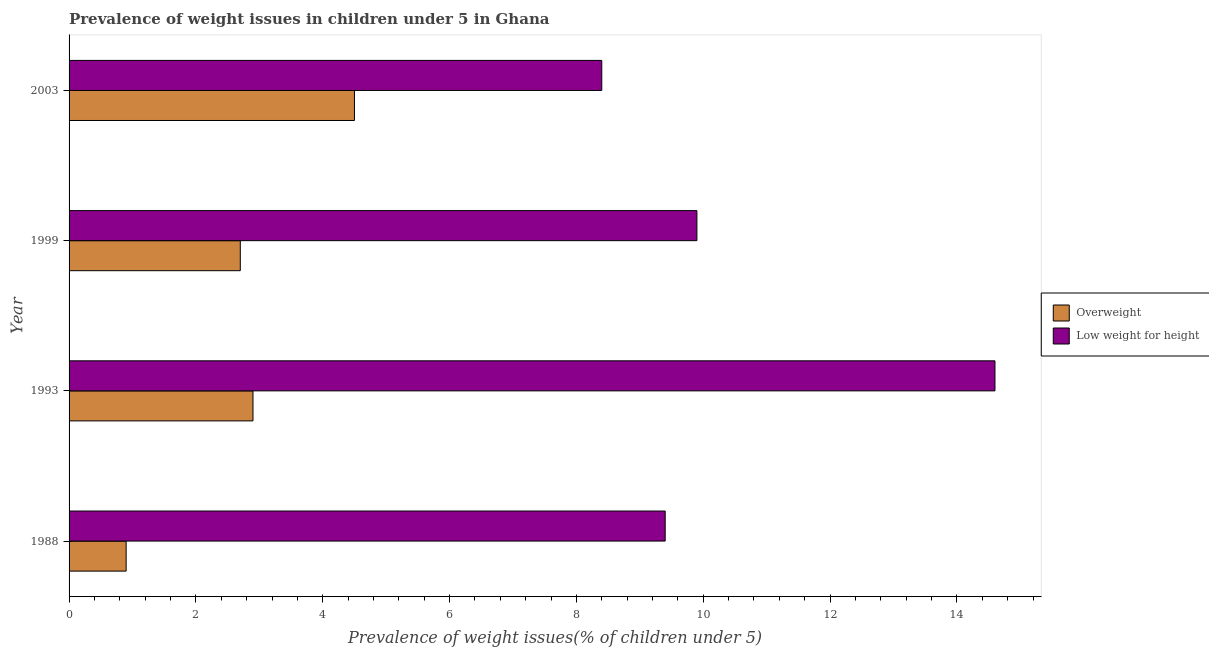How many different coloured bars are there?
Give a very brief answer. 2. How many groups of bars are there?
Offer a very short reply. 4. Are the number of bars per tick equal to the number of legend labels?
Offer a very short reply. Yes. How many bars are there on the 3rd tick from the top?
Keep it short and to the point. 2. What is the percentage of underweight children in 1993?
Ensure brevity in your answer.  14.6. Across all years, what is the maximum percentage of overweight children?
Your answer should be very brief. 4.5. Across all years, what is the minimum percentage of overweight children?
Give a very brief answer. 0.9. In which year was the percentage of overweight children maximum?
Your answer should be compact. 2003. What is the total percentage of underweight children in the graph?
Ensure brevity in your answer.  42.3. What is the difference between the percentage of overweight children in 1988 and that in 1999?
Provide a short and direct response. -1.8. What is the difference between the percentage of underweight children in 1988 and the percentage of overweight children in 2003?
Provide a succinct answer. 4.9. What is the average percentage of overweight children per year?
Your answer should be compact. 2.75. What is the ratio of the percentage of underweight children in 1993 to that in 2003?
Ensure brevity in your answer.  1.74. Is the percentage of overweight children in 1999 less than that in 2003?
Your answer should be very brief. Yes. Is the difference between the percentage of underweight children in 1988 and 2003 greater than the difference between the percentage of overweight children in 1988 and 2003?
Offer a terse response. Yes. What is the difference between the highest and the second highest percentage of overweight children?
Offer a very short reply. 1.6. What does the 1st bar from the top in 1993 represents?
Your answer should be very brief. Low weight for height. What does the 2nd bar from the bottom in 2003 represents?
Provide a short and direct response. Low weight for height. Are all the bars in the graph horizontal?
Provide a short and direct response. Yes. How many years are there in the graph?
Offer a very short reply. 4. Does the graph contain grids?
Offer a terse response. No. Where does the legend appear in the graph?
Provide a succinct answer. Center right. What is the title of the graph?
Keep it short and to the point. Prevalence of weight issues in children under 5 in Ghana. Does "Food" appear as one of the legend labels in the graph?
Keep it short and to the point. No. What is the label or title of the X-axis?
Give a very brief answer. Prevalence of weight issues(% of children under 5). What is the label or title of the Y-axis?
Make the answer very short. Year. What is the Prevalence of weight issues(% of children under 5) in Overweight in 1988?
Keep it short and to the point. 0.9. What is the Prevalence of weight issues(% of children under 5) of Low weight for height in 1988?
Your answer should be very brief. 9.4. What is the Prevalence of weight issues(% of children under 5) of Overweight in 1993?
Offer a very short reply. 2.9. What is the Prevalence of weight issues(% of children under 5) of Low weight for height in 1993?
Provide a succinct answer. 14.6. What is the Prevalence of weight issues(% of children under 5) of Overweight in 1999?
Your answer should be very brief. 2.7. What is the Prevalence of weight issues(% of children under 5) of Low weight for height in 1999?
Your answer should be compact. 9.9. What is the Prevalence of weight issues(% of children under 5) in Low weight for height in 2003?
Keep it short and to the point. 8.4. Across all years, what is the maximum Prevalence of weight issues(% of children under 5) of Low weight for height?
Provide a short and direct response. 14.6. Across all years, what is the minimum Prevalence of weight issues(% of children under 5) in Overweight?
Provide a succinct answer. 0.9. Across all years, what is the minimum Prevalence of weight issues(% of children under 5) in Low weight for height?
Your response must be concise. 8.4. What is the total Prevalence of weight issues(% of children under 5) of Low weight for height in the graph?
Ensure brevity in your answer.  42.3. What is the difference between the Prevalence of weight issues(% of children under 5) of Overweight in 1988 and that in 1993?
Provide a short and direct response. -2. What is the difference between the Prevalence of weight issues(% of children under 5) in Low weight for height in 1988 and that in 1993?
Provide a short and direct response. -5.2. What is the difference between the Prevalence of weight issues(% of children under 5) of Overweight in 1988 and that in 1999?
Provide a short and direct response. -1.8. What is the difference between the Prevalence of weight issues(% of children under 5) in Low weight for height in 1988 and that in 1999?
Ensure brevity in your answer.  -0.5. What is the difference between the Prevalence of weight issues(% of children under 5) of Overweight in 1988 and that in 2003?
Provide a short and direct response. -3.6. What is the difference between the Prevalence of weight issues(% of children under 5) of Low weight for height in 1993 and that in 1999?
Ensure brevity in your answer.  4.7. What is the difference between the Prevalence of weight issues(% of children under 5) of Overweight in 1993 and that in 2003?
Provide a short and direct response. -1.6. What is the difference between the Prevalence of weight issues(% of children under 5) of Low weight for height in 1993 and that in 2003?
Your response must be concise. 6.2. What is the difference between the Prevalence of weight issues(% of children under 5) of Overweight in 1999 and that in 2003?
Give a very brief answer. -1.8. What is the difference between the Prevalence of weight issues(% of children under 5) in Overweight in 1988 and the Prevalence of weight issues(% of children under 5) in Low weight for height in 1993?
Provide a short and direct response. -13.7. What is the difference between the Prevalence of weight issues(% of children under 5) of Overweight in 1988 and the Prevalence of weight issues(% of children under 5) of Low weight for height in 1999?
Your response must be concise. -9. What is the difference between the Prevalence of weight issues(% of children under 5) in Overweight in 1993 and the Prevalence of weight issues(% of children under 5) in Low weight for height in 1999?
Keep it short and to the point. -7. What is the average Prevalence of weight issues(% of children under 5) of Overweight per year?
Keep it short and to the point. 2.75. What is the average Prevalence of weight issues(% of children under 5) of Low weight for height per year?
Provide a succinct answer. 10.57. In the year 1988, what is the difference between the Prevalence of weight issues(% of children under 5) of Overweight and Prevalence of weight issues(% of children under 5) of Low weight for height?
Your response must be concise. -8.5. What is the ratio of the Prevalence of weight issues(% of children under 5) of Overweight in 1988 to that in 1993?
Your answer should be very brief. 0.31. What is the ratio of the Prevalence of weight issues(% of children under 5) of Low weight for height in 1988 to that in 1993?
Ensure brevity in your answer.  0.64. What is the ratio of the Prevalence of weight issues(% of children under 5) in Low weight for height in 1988 to that in 1999?
Ensure brevity in your answer.  0.95. What is the ratio of the Prevalence of weight issues(% of children under 5) in Low weight for height in 1988 to that in 2003?
Provide a succinct answer. 1.12. What is the ratio of the Prevalence of weight issues(% of children under 5) of Overweight in 1993 to that in 1999?
Keep it short and to the point. 1.07. What is the ratio of the Prevalence of weight issues(% of children under 5) of Low weight for height in 1993 to that in 1999?
Give a very brief answer. 1.47. What is the ratio of the Prevalence of weight issues(% of children under 5) of Overweight in 1993 to that in 2003?
Provide a succinct answer. 0.64. What is the ratio of the Prevalence of weight issues(% of children under 5) in Low weight for height in 1993 to that in 2003?
Keep it short and to the point. 1.74. What is the ratio of the Prevalence of weight issues(% of children under 5) of Overweight in 1999 to that in 2003?
Offer a terse response. 0.6. What is the ratio of the Prevalence of weight issues(% of children under 5) of Low weight for height in 1999 to that in 2003?
Make the answer very short. 1.18. What is the difference between the highest and the second highest Prevalence of weight issues(% of children under 5) in Low weight for height?
Offer a terse response. 4.7. What is the difference between the highest and the lowest Prevalence of weight issues(% of children under 5) in Overweight?
Keep it short and to the point. 3.6. What is the difference between the highest and the lowest Prevalence of weight issues(% of children under 5) of Low weight for height?
Keep it short and to the point. 6.2. 